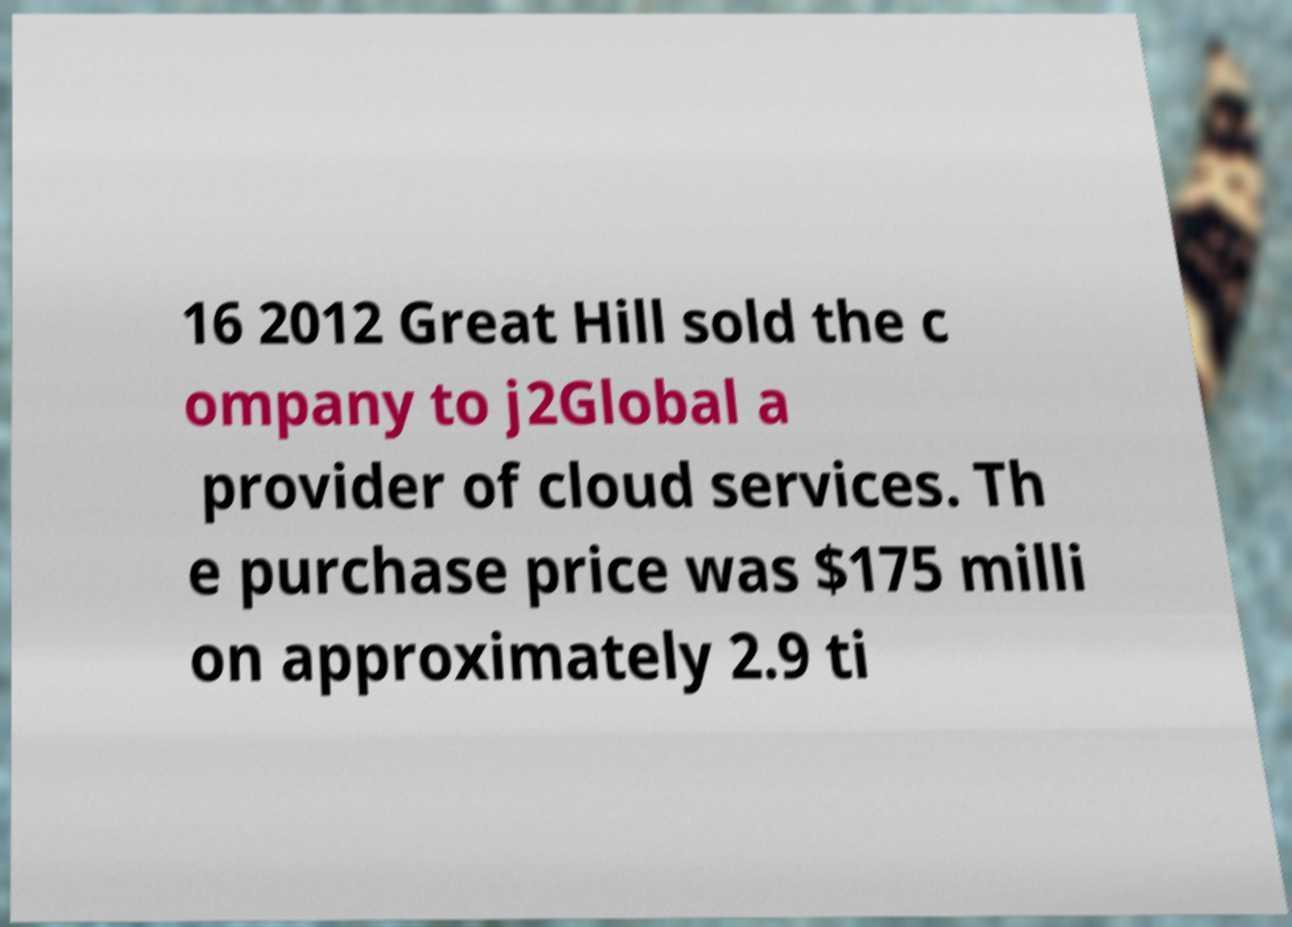I need the written content from this picture converted into text. Can you do that? 16 2012 Great Hill sold the c ompany to j2Global a provider of cloud services. Th e purchase price was $175 milli on approximately 2.9 ti 